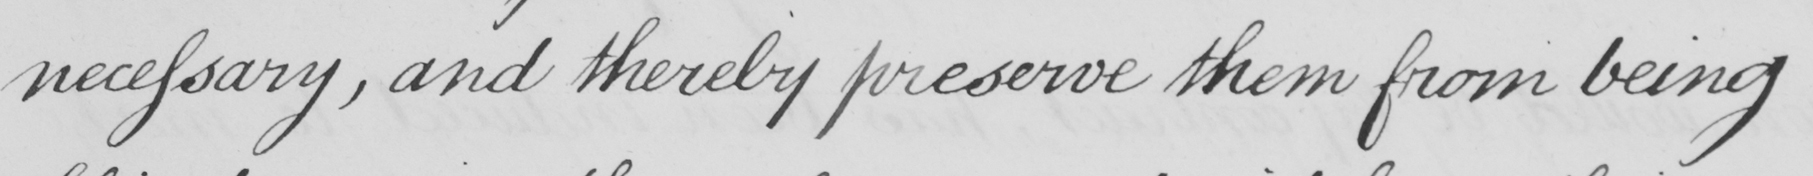What text is written in this handwritten line? necessary, and thereby preserve them from being 